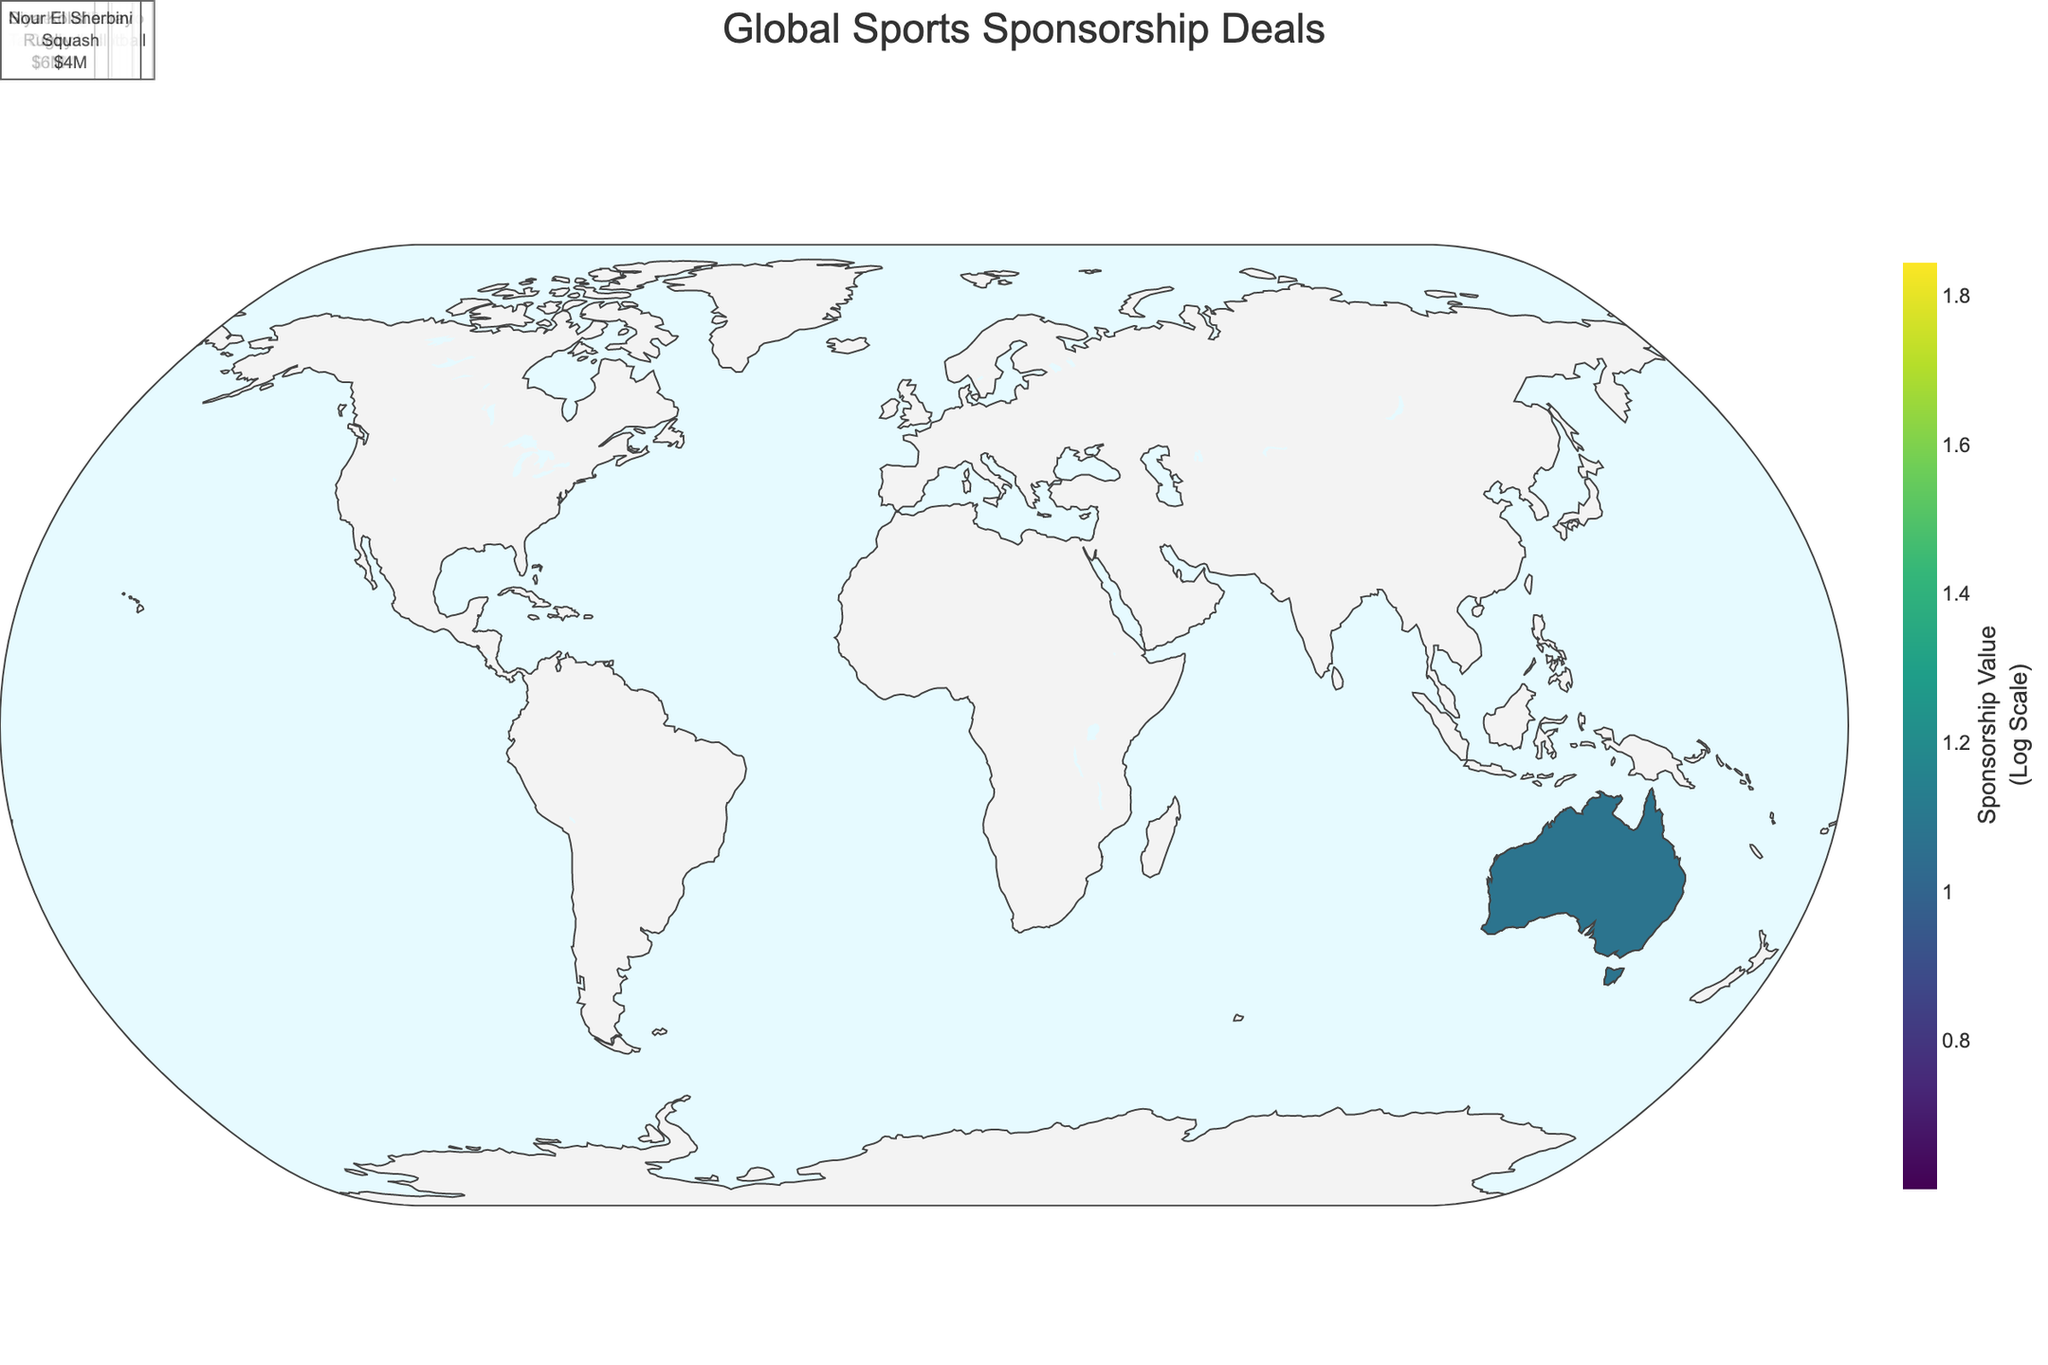Which region has the highest total sponsorship value? To find the region with the highest total sponsorship value, sum up the sponsorship values of the athletes for each region. North America: 50 (LeBron James) + 45 (Tom Brady) = 95. Europe: 70 (Cristiano Ronaldo) + 55 (Lewis Hamilton) = 125. Asia: 35 (Naomi Osaka) + 10 (Ma Long) = 45. South America: 40 (Neymar Jr.) + 8 (Fernanda Garay) = 48. Australia: 15 (Emma McKeon) + 12 (Steve Smith) = 27. Africa: 20 (Eliud Kipchoge) + 6 (Siya Kolisi) = 26. Middle East: 30 (Rory McIlroy) + 4 (Nour El Sherbini) = 34. The highest total is in Europe.
Answer: Europe Who has the highest individual sponsorship value and from which sport? Check each athlete's sponsorship value and identify the highest one. Cristiano Ronaldo has the highest value of 70 million USD. His sport is soccer.
Answer: Cristiano Ronaldo, Soccer What is the average sponsorship value in North America? Sum up the sponsorship values for North America, which are 50 (LeBron James) and 45 (Tom Brady). The total is 50 + 45 = 95. There are 2 athletes, so the average is 95 / 2 = 47.5 million USD.
Answer: 47.5 million USD Which region has the lowest individual sponsorship deal? Identify the athlete with the lowest sponsorship value and then check their region. Nour El Sherbini from the Middle East has the lowest value at 4 million USD.
Answer: Middle East What is the total sponsorship value for athletes in Asia? Sum up the sponsorship values for the Asian athletes. Naomi Osaka: 35 million USD and Ma Long: 10 million USD. The total value is 35 + 10 = 45 million USD.
Answer: 45 million USD How many athletes in the plot have sponsorship values above 50 million USD? Count the athletes whose sponsorship values are more than 50 million USD. Cristiano Ronaldo (70) and Lewis Hamilton (55) are the only ones with values above 50. There are 2 such athletes.
Answer: 2 Which regions feature athletes from non-team sports and what are their sports? Identify athletes who participate in individual sports and their corresponding regions. Asia (Tennis: Naomi Osaka), Australia (Swimming: Emma McKeon, Cricket: Steve Smith), Africa (Track and Field: Eliud Kipchoge, Rugby: Siya Kolisi), and Middle East (Golf: Rory McIlroy, Squash: Nour El Sherbini). Note that tennis, swimming, cricket, track and field, rugby, golf, and squash are all individual sports.
Answer: Asia, Australia, Africa, Middle East What is the median sponsorship value among all athletes? List all values: 70, 55, 50, 45, 40, 35, 30, 20, 15, 12, 10, 8, 6, 4. There are 14 values, so the median is the average of the 7th and 8th values: (30 + 20) / 2 = 25 million USD.
Answer: 25 million USD Which athlete represents Europe in Formula 1? Look for the athlete associated with Europe in the sport of Formula 1. Lewis Hamilton represents Europe in Formula 1.
Answer: Lewis Hamilton In which region does the highest-paid track and field athlete come from? Identify the track and field athlete and check their region. Eliud Kipchoge is the highest-paid track and field athlete with 20 million USD, from Africa.
Answer: Africa 